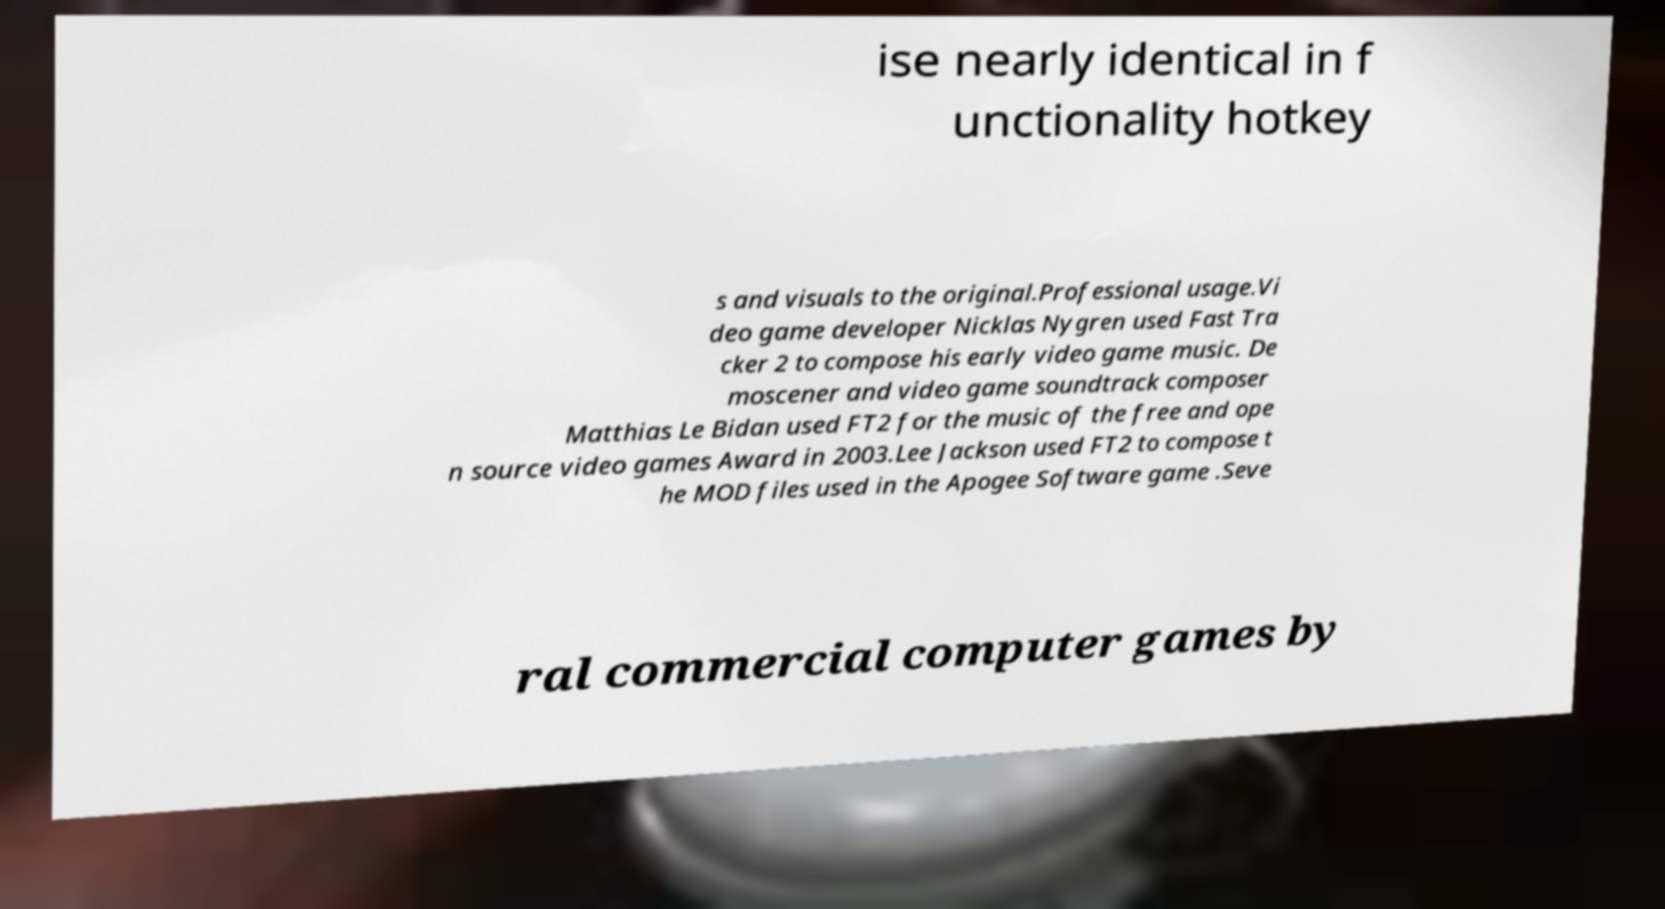What messages or text are displayed in this image? I need them in a readable, typed format. ise nearly identical in f unctionality hotkey s and visuals to the original.Professional usage.Vi deo game developer Nicklas Nygren used Fast Tra cker 2 to compose his early video game music. De moscener and video game soundtrack composer Matthias Le Bidan used FT2 for the music of the free and ope n source video games Award in 2003.Lee Jackson used FT2 to compose t he MOD files used in the Apogee Software game .Seve ral commercial computer games by 